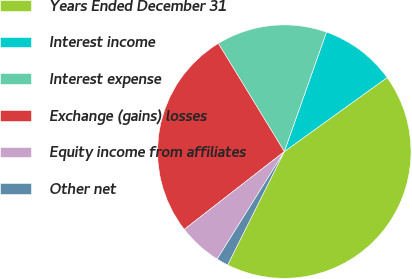Convert chart. <chart><loc_0><loc_0><loc_500><loc_500><pie_chart><fcel>Years Ended December 31<fcel>Interest income<fcel>Interest expense<fcel>Exchange (gains) losses<fcel>Equity income from affiliates<fcel>Other net<nl><fcel>42.31%<fcel>9.67%<fcel>14.11%<fcel>26.81%<fcel>5.59%<fcel>1.51%<nl></chart> 